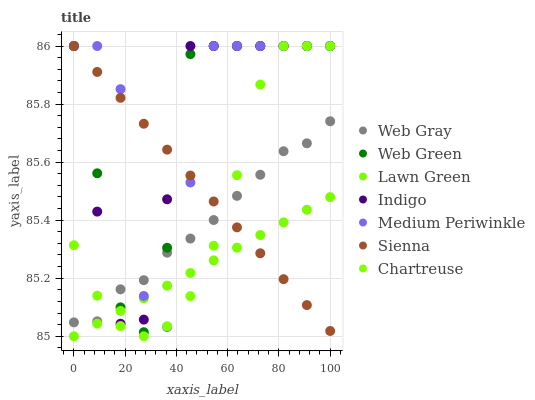Does Lawn Green have the minimum area under the curve?
Answer yes or no. Yes. Does Medium Periwinkle have the maximum area under the curve?
Answer yes or no. Yes. Does Web Gray have the minimum area under the curve?
Answer yes or no. No. Does Web Gray have the maximum area under the curve?
Answer yes or no. No. Is Sienna the smoothest?
Answer yes or no. Yes. Is Medium Periwinkle the roughest?
Answer yes or no. Yes. Is Web Gray the smoothest?
Answer yes or no. No. Is Web Gray the roughest?
Answer yes or no. No. Does Lawn Green have the lowest value?
Answer yes or no. Yes. Does Indigo have the lowest value?
Answer yes or no. No. Does Chartreuse have the highest value?
Answer yes or no. Yes. Does Web Gray have the highest value?
Answer yes or no. No. Is Lawn Green less than Web Gray?
Answer yes or no. Yes. Is Web Gray greater than Lawn Green?
Answer yes or no. Yes. Does Lawn Green intersect Web Green?
Answer yes or no. Yes. Is Lawn Green less than Web Green?
Answer yes or no. No. Is Lawn Green greater than Web Green?
Answer yes or no. No. Does Lawn Green intersect Web Gray?
Answer yes or no. No. 